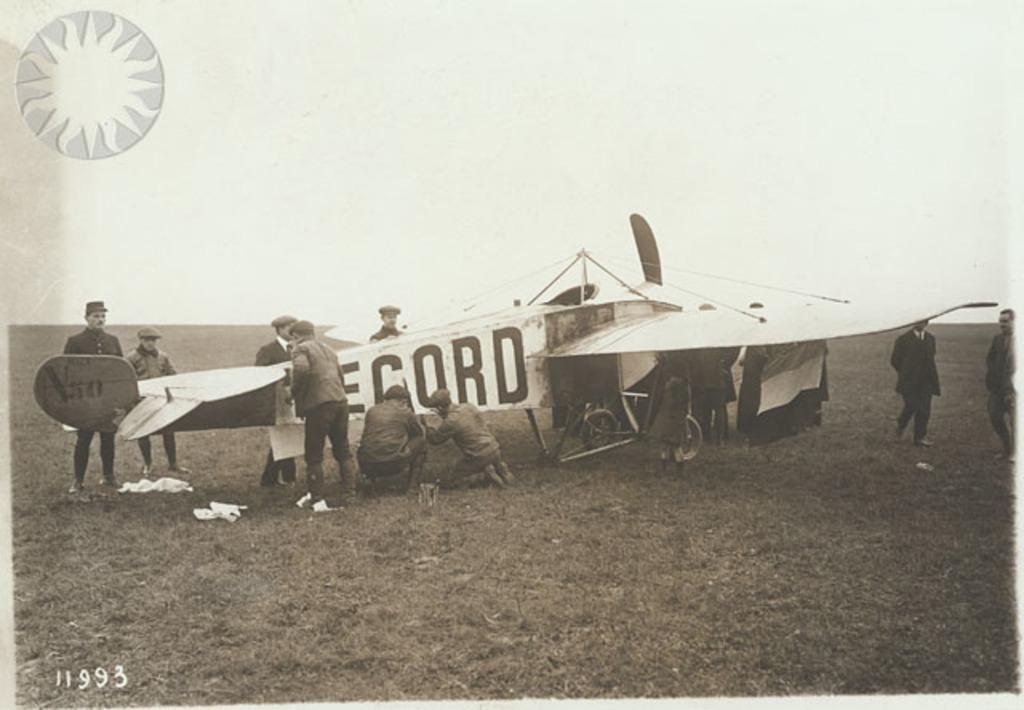Describe this image in one or two sentences. In this image I can see an old photograph in which I can see an aircraft which is black and white in color. I can see few persons are standing around the aircraft. In the background I can see the sky. 